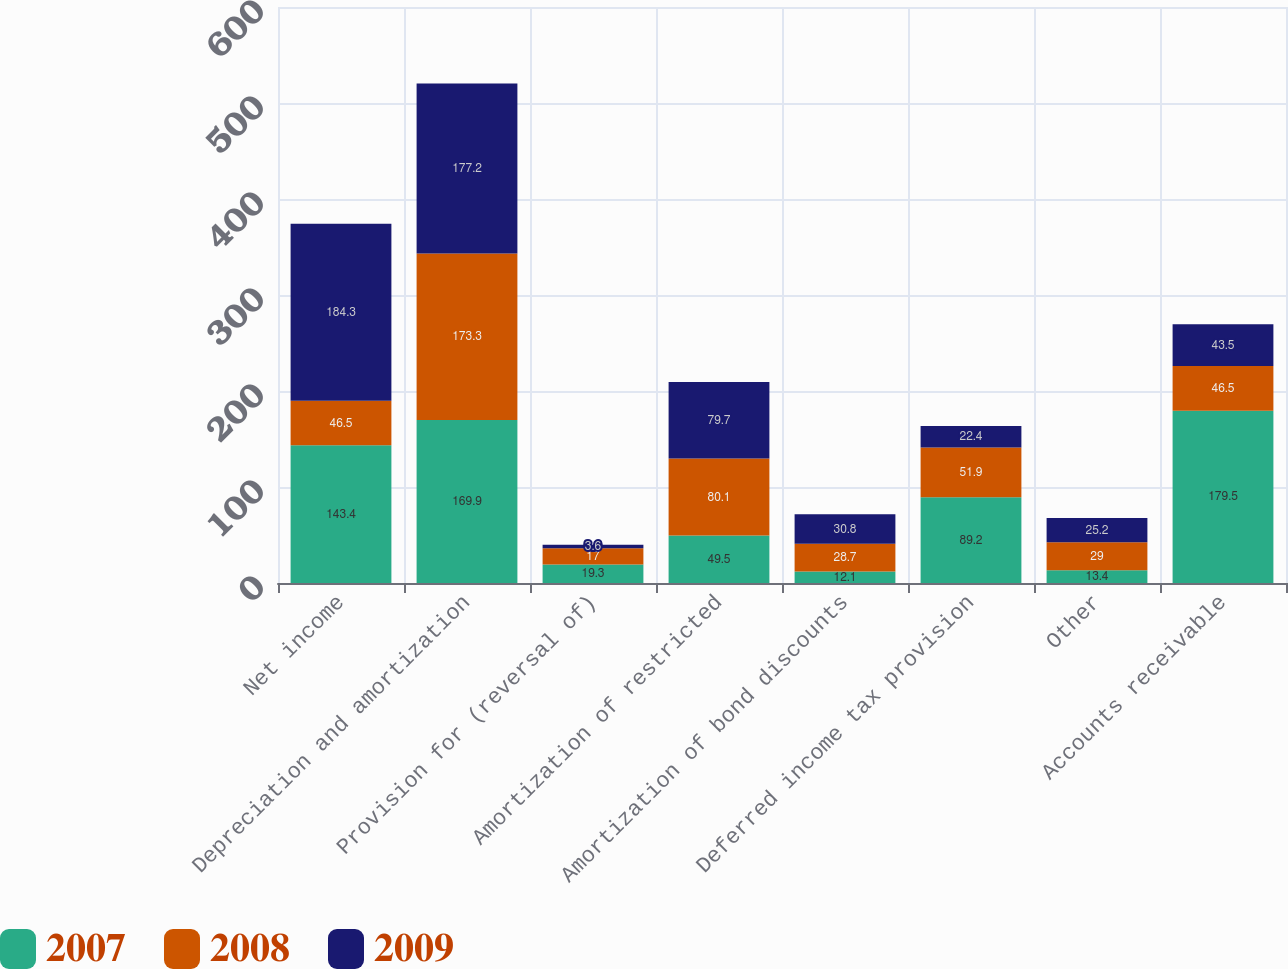Convert chart to OTSL. <chart><loc_0><loc_0><loc_500><loc_500><stacked_bar_chart><ecel><fcel>Net income<fcel>Depreciation and amortization<fcel>Provision for (reversal of)<fcel>Amortization of restricted<fcel>Amortization of bond discounts<fcel>Deferred income tax provision<fcel>Other<fcel>Accounts receivable<nl><fcel>2007<fcel>143.4<fcel>169.9<fcel>19.3<fcel>49.5<fcel>12.1<fcel>89.2<fcel>13.4<fcel>179.5<nl><fcel>2008<fcel>46.5<fcel>173.3<fcel>17<fcel>80.1<fcel>28.7<fcel>51.9<fcel>29<fcel>46.5<nl><fcel>2009<fcel>184.3<fcel>177.2<fcel>3.6<fcel>79.7<fcel>30.8<fcel>22.4<fcel>25.2<fcel>43.5<nl></chart> 